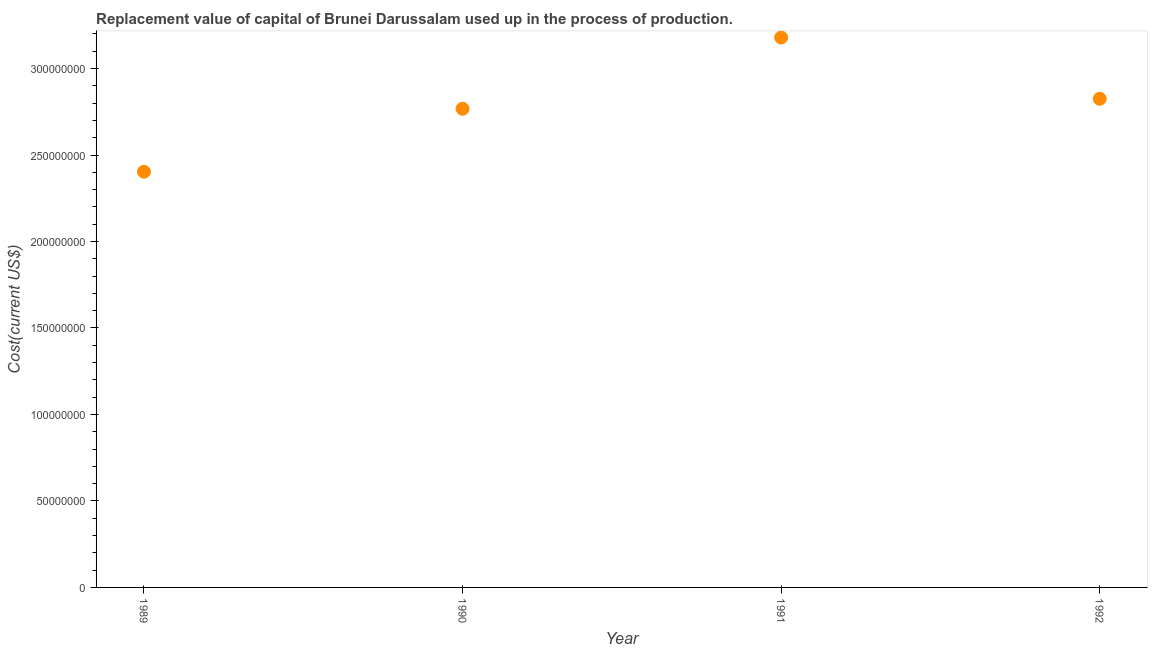What is the consumption of fixed capital in 1990?
Make the answer very short. 2.77e+08. Across all years, what is the maximum consumption of fixed capital?
Provide a succinct answer. 3.18e+08. Across all years, what is the minimum consumption of fixed capital?
Give a very brief answer. 2.40e+08. In which year was the consumption of fixed capital maximum?
Ensure brevity in your answer.  1991. In which year was the consumption of fixed capital minimum?
Provide a short and direct response. 1989. What is the sum of the consumption of fixed capital?
Your answer should be compact. 1.12e+09. What is the difference between the consumption of fixed capital in 1990 and 1992?
Ensure brevity in your answer.  -5.77e+06. What is the average consumption of fixed capital per year?
Give a very brief answer. 2.79e+08. What is the median consumption of fixed capital?
Give a very brief answer. 2.80e+08. In how many years, is the consumption of fixed capital greater than 130000000 US$?
Give a very brief answer. 4. Do a majority of the years between 1992 and 1989 (inclusive) have consumption of fixed capital greater than 170000000 US$?
Provide a succinct answer. Yes. What is the ratio of the consumption of fixed capital in 1990 to that in 1991?
Make the answer very short. 0.87. What is the difference between the highest and the second highest consumption of fixed capital?
Keep it short and to the point. 3.54e+07. What is the difference between the highest and the lowest consumption of fixed capital?
Make the answer very short. 7.76e+07. Does the consumption of fixed capital monotonically increase over the years?
Give a very brief answer. No. How many dotlines are there?
Your answer should be compact. 1. How many years are there in the graph?
Your response must be concise. 4. What is the title of the graph?
Ensure brevity in your answer.  Replacement value of capital of Brunei Darussalam used up in the process of production. What is the label or title of the Y-axis?
Ensure brevity in your answer.  Cost(current US$). What is the Cost(current US$) in 1989?
Keep it short and to the point. 2.40e+08. What is the Cost(current US$) in 1990?
Provide a short and direct response. 2.77e+08. What is the Cost(current US$) in 1991?
Ensure brevity in your answer.  3.18e+08. What is the Cost(current US$) in 1992?
Your answer should be compact. 2.83e+08. What is the difference between the Cost(current US$) in 1989 and 1990?
Make the answer very short. -3.64e+07. What is the difference between the Cost(current US$) in 1989 and 1991?
Give a very brief answer. -7.76e+07. What is the difference between the Cost(current US$) in 1989 and 1992?
Offer a terse response. -4.22e+07. What is the difference between the Cost(current US$) in 1990 and 1991?
Give a very brief answer. -4.12e+07. What is the difference between the Cost(current US$) in 1990 and 1992?
Your answer should be very brief. -5.77e+06. What is the difference between the Cost(current US$) in 1991 and 1992?
Offer a very short reply. 3.54e+07. What is the ratio of the Cost(current US$) in 1989 to that in 1990?
Your answer should be very brief. 0.87. What is the ratio of the Cost(current US$) in 1989 to that in 1991?
Your answer should be very brief. 0.76. What is the ratio of the Cost(current US$) in 1989 to that in 1992?
Your answer should be compact. 0.85. What is the ratio of the Cost(current US$) in 1990 to that in 1991?
Offer a terse response. 0.87. What is the ratio of the Cost(current US$) in 1990 to that in 1992?
Offer a very short reply. 0.98. What is the ratio of the Cost(current US$) in 1991 to that in 1992?
Your answer should be very brief. 1.12. 